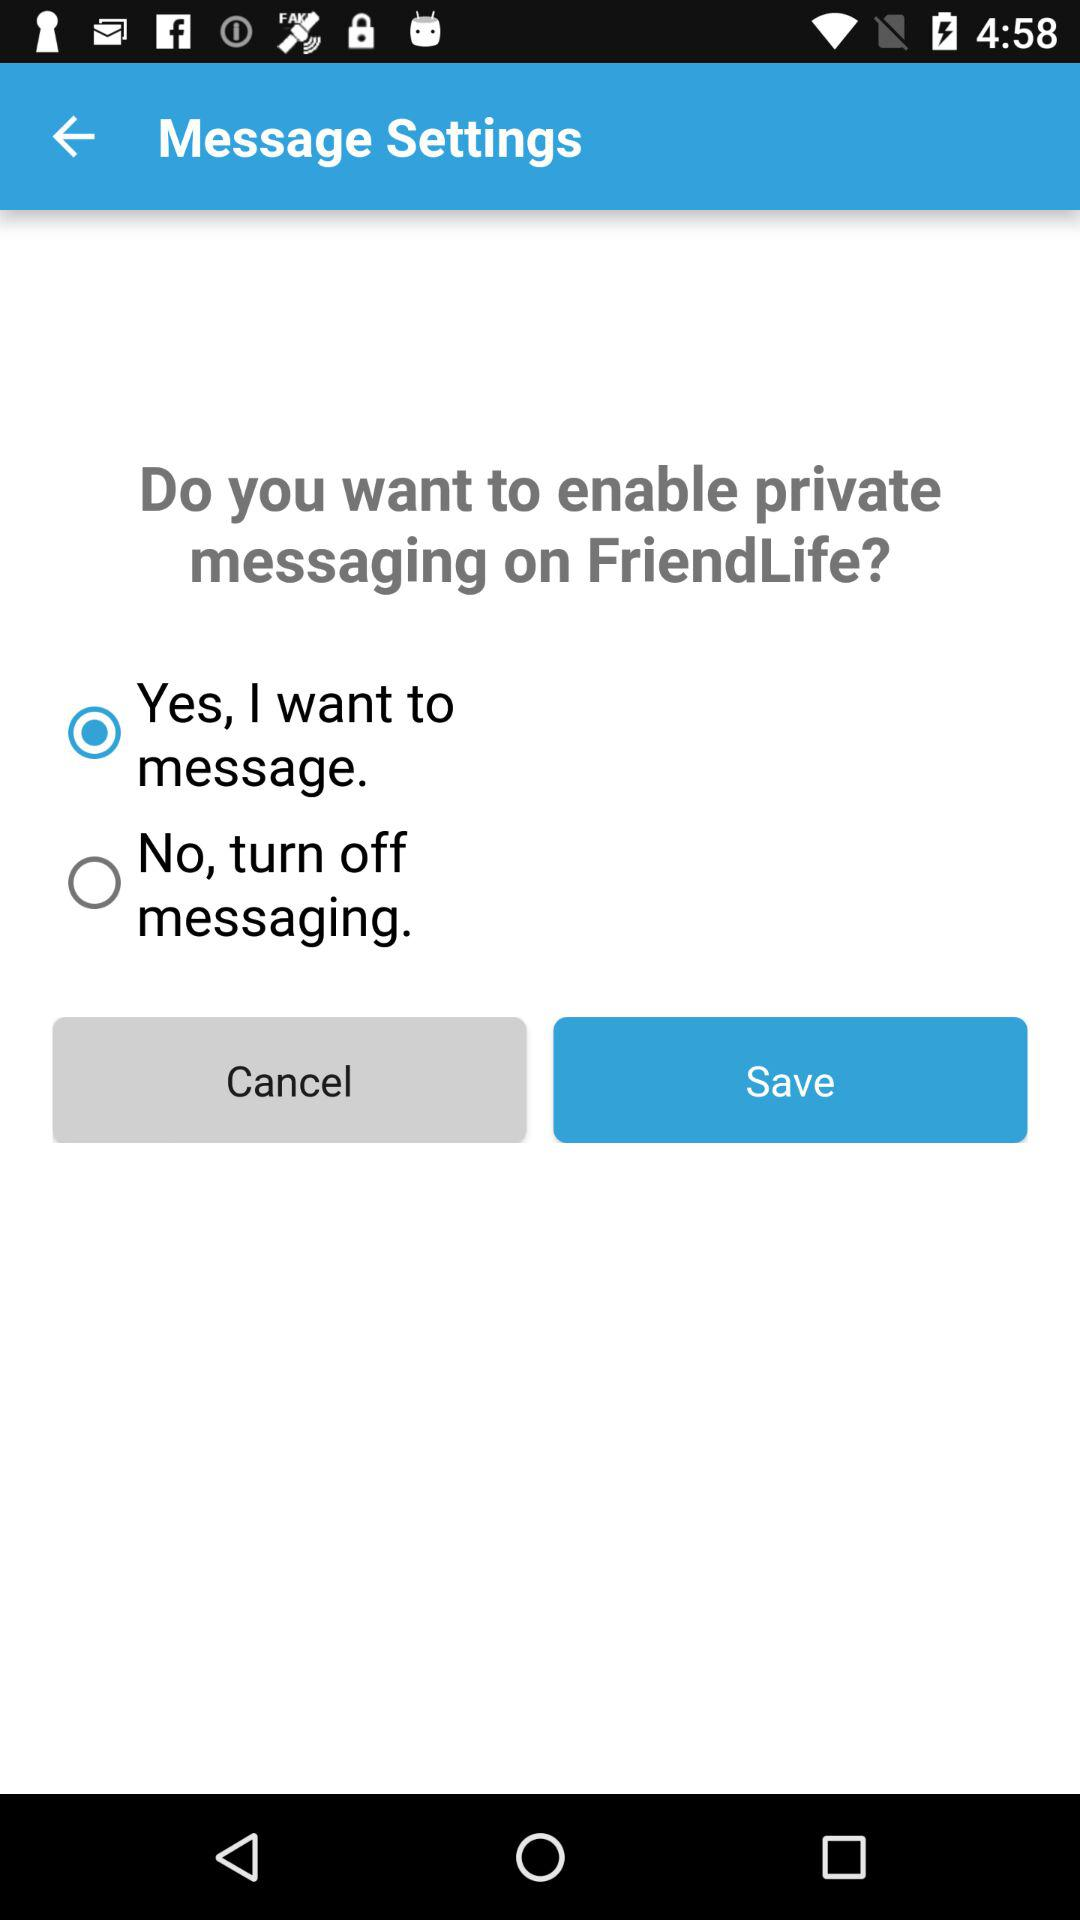Which option is not selected? The option not selected is "No, turn off messaging". 